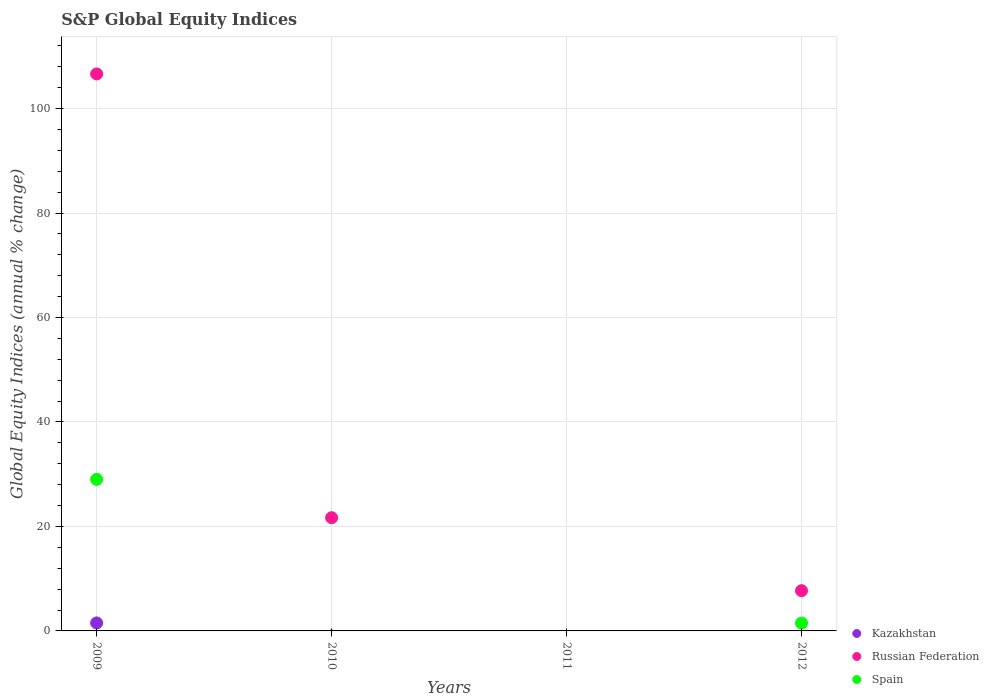How many different coloured dotlines are there?
Provide a succinct answer. 3. Across all years, what is the maximum global equity indices in Russian Federation?
Offer a terse response. 106.63. In which year was the global equity indices in Spain maximum?
Make the answer very short. 2009. What is the total global equity indices in Kazakhstan in the graph?
Provide a succinct answer. 1.53. What is the difference between the global equity indices in Russian Federation in 2009 and that in 2010?
Give a very brief answer. 84.96. What is the difference between the global equity indices in Kazakhstan in 2010 and the global equity indices in Spain in 2012?
Keep it short and to the point. -1.5. What is the average global equity indices in Russian Federation per year?
Your answer should be very brief. 34. In the year 2009, what is the difference between the global equity indices in Russian Federation and global equity indices in Spain?
Offer a terse response. 77.62. What is the ratio of the global equity indices in Russian Federation in 2010 to that in 2012?
Provide a short and direct response. 2.81. Is the difference between the global equity indices in Russian Federation in 2009 and 2012 greater than the difference between the global equity indices in Spain in 2009 and 2012?
Offer a terse response. Yes. What is the difference between the highest and the second highest global equity indices in Russian Federation?
Provide a succinct answer. 84.96. What is the difference between the highest and the lowest global equity indices in Russian Federation?
Offer a very short reply. 106.63. Is it the case that in every year, the sum of the global equity indices in Russian Federation and global equity indices in Spain  is greater than the global equity indices in Kazakhstan?
Your response must be concise. No. Is the global equity indices in Spain strictly greater than the global equity indices in Russian Federation over the years?
Your response must be concise. No. How many dotlines are there?
Your answer should be compact. 3. Are the values on the major ticks of Y-axis written in scientific E-notation?
Give a very brief answer. No. Where does the legend appear in the graph?
Ensure brevity in your answer.  Bottom right. How many legend labels are there?
Offer a very short reply. 3. How are the legend labels stacked?
Give a very brief answer. Vertical. What is the title of the graph?
Provide a short and direct response. S&P Global Equity Indices. Does "Barbados" appear as one of the legend labels in the graph?
Offer a terse response. No. What is the label or title of the X-axis?
Your response must be concise. Years. What is the label or title of the Y-axis?
Provide a short and direct response. Global Equity Indices (annual % change). What is the Global Equity Indices (annual % change) in Kazakhstan in 2009?
Make the answer very short. 1.53. What is the Global Equity Indices (annual % change) of Russian Federation in 2009?
Ensure brevity in your answer.  106.63. What is the Global Equity Indices (annual % change) in Spain in 2009?
Give a very brief answer. 29.02. What is the Global Equity Indices (annual % change) in Kazakhstan in 2010?
Offer a terse response. 0. What is the Global Equity Indices (annual % change) of Russian Federation in 2010?
Provide a short and direct response. 21.67. What is the Global Equity Indices (annual % change) in Spain in 2010?
Offer a terse response. 0. What is the Global Equity Indices (annual % change) in Spain in 2011?
Provide a succinct answer. 0. What is the Global Equity Indices (annual % change) in Kazakhstan in 2012?
Provide a short and direct response. 0. What is the Global Equity Indices (annual % change) of Russian Federation in 2012?
Provide a short and direct response. 7.7. What is the Global Equity Indices (annual % change) in Spain in 2012?
Provide a succinct answer. 1.5. Across all years, what is the maximum Global Equity Indices (annual % change) of Kazakhstan?
Provide a short and direct response. 1.53. Across all years, what is the maximum Global Equity Indices (annual % change) of Russian Federation?
Ensure brevity in your answer.  106.63. Across all years, what is the maximum Global Equity Indices (annual % change) of Spain?
Ensure brevity in your answer.  29.02. Across all years, what is the minimum Global Equity Indices (annual % change) of Kazakhstan?
Your answer should be very brief. 0. What is the total Global Equity Indices (annual % change) of Kazakhstan in the graph?
Keep it short and to the point. 1.53. What is the total Global Equity Indices (annual % change) of Russian Federation in the graph?
Give a very brief answer. 136.01. What is the total Global Equity Indices (annual % change) in Spain in the graph?
Make the answer very short. 30.52. What is the difference between the Global Equity Indices (annual % change) of Russian Federation in 2009 and that in 2010?
Provide a succinct answer. 84.96. What is the difference between the Global Equity Indices (annual % change) in Russian Federation in 2009 and that in 2012?
Offer a terse response. 98.93. What is the difference between the Global Equity Indices (annual % change) in Spain in 2009 and that in 2012?
Your response must be concise. 27.51. What is the difference between the Global Equity Indices (annual % change) in Russian Federation in 2010 and that in 2012?
Your answer should be very brief. 13.97. What is the difference between the Global Equity Indices (annual % change) in Kazakhstan in 2009 and the Global Equity Indices (annual % change) in Russian Federation in 2010?
Give a very brief answer. -20.14. What is the difference between the Global Equity Indices (annual % change) of Kazakhstan in 2009 and the Global Equity Indices (annual % change) of Russian Federation in 2012?
Offer a very short reply. -6.17. What is the difference between the Global Equity Indices (annual % change) in Kazakhstan in 2009 and the Global Equity Indices (annual % change) in Spain in 2012?
Offer a very short reply. 0.03. What is the difference between the Global Equity Indices (annual % change) in Russian Federation in 2009 and the Global Equity Indices (annual % change) in Spain in 2012?
Offer a terse response. 105.13. What is the difference between the Global Equity Indices (annual % change) in Russian Federation in 2010 and the Global Equity Indices (annual % change) in Spain in 2012?
Your answer should be compact. 20.17. What is the average Global Equity Indices (annual % change) in Kazakhstan per year?
Keep it short and to the point. 0.38. What is the average Global Equity Indices (annual % change) in Russian Federation per year?
Make the answer very short. 34. What is the average Global Equity Indices (annual % change) in Spain per year?
Provide a succinct answer. 7.63. In the year 2009, what is the difference between the Global Equity Indices (annual % change) of Kazakhstan and Global Equity Indices (annual % change) of Russian Federation?
Offer a terse response. -105.1. In the year 2009, what is the difference between the Global Equity Indices (annual % change) of Kazakhstan and Global Equity Indices (annual % change) of Spain?
Make the answer very short. -27.49. In the year 2009, what is the difference between the Global Equity Indices (annual % change) in Russian Federation and Global Equity Indices (annual % change) in Spain?
Keep it short and to the point. 77.61. In the year 2012, what is the difference between the Global Equity Indices (annual % change) in Russian Federation and Global Equity Indices (annual % change) in Spain?
Your answer should be very brief. 6.2. What is the ratio of the Global Equity Indices (annual % change) of Russian Federation in 2009 to that in 2010?
Ensure brevity in your answer.  4.92. What is the ratio of the Global Equity Indices (annual % change) of Russian Federation in 2009 to that in 2012?
Keep it short and to the point. 13.84. What is the ratio of the Global Equity Indices (annual % change) in Spain in 2009 to that in 2012?
Offer a terse response. 19.3. What is the ratio of the Global Equity Indices (annual % change) of Russian Federation in 2010 to that in 2012?
Your response must be concise. 2.81. What is the difference between the highest and the second highest Global Equity Indices (annual % change) in Russian Federation?
Give a very brief answer. 84.96. What is the difference between the highest and the lowest Global Equity Indices (annual % change) in Kazakhstan?
Make the answer very short. 1.53. What is the difference between the highest and the lowest Global Equity Indices (annual % change) of Russian Federation?
Keep it short and to the point. 106.63. What is the difference between the highest and the lowest Global Equity Indices (annual % change) in Spain?
Ensure brevity in your answer.  29.02. 